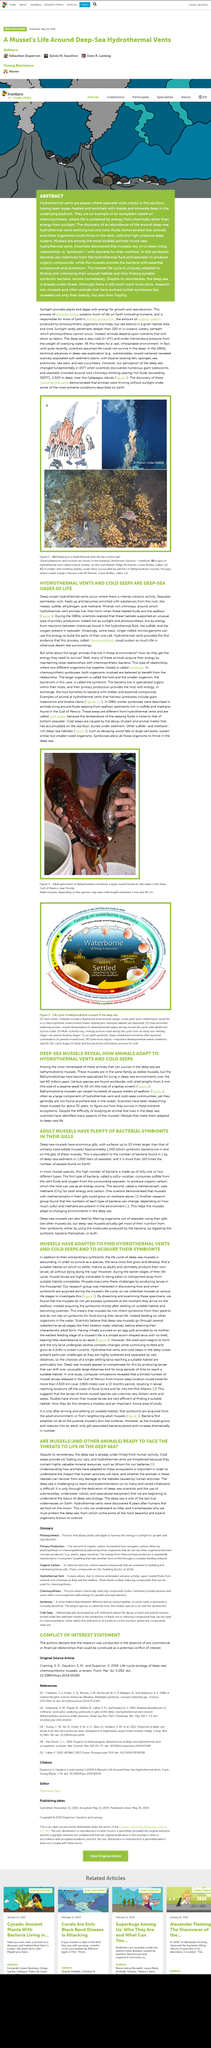Indicate a few pertinent items in this graphic. Sunlight provides plants and algae with energy. Yes, energy is used by plants and algae for growth and reproduction. Photosynthesis sustains much of life on Earth, as it provides the energy and nutrients necessary for the survival of various organisms. In Symbiosis, two distinct organisms reside closely together and form a mutually beneficial relationship, where each organism derives some advantage from the other. In the picture, a man is holding an adult specimen of Bathymodiolus heckerae, a large mussel. 